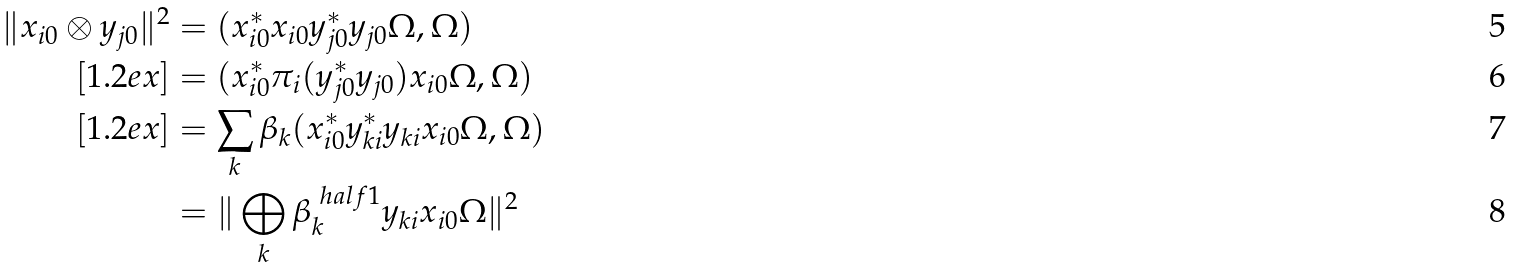<formula> <loc_0><loc_0><loc_500><loc_500>\| x _ { i 0 } \otimes y _ { j 0 } \| ^ { 2 } & = ( x _ { i 0 } ^ { * } x _ { i 0 } y _ { j 0 } ^ { * } y _ { j 0 } \Omega , \Omega ) \\ [ 1 . 2 e x ] & = ( x _ { i 0 } ^ { * } \pi _ { i } ( y _ { j 0 } ^ { * } y _ { j 0 } ) x _ { i 0 } \Omega , \Omega ) \\ [ 1 . 2 e x ] & = \sum _ { k } \beta _ { k } ( x _ { i 0 } ^ { * } y _ { k i } ^ { * } y _ { k i } x _ { i 0 } \Omega , \Omega ) \\ & = \| \bigoplus _ { k } \beta _ { k } ^ { \ h a l f { 1 } } y _ { k i } x _ { i 0 } \Omega \| ^ { 2 }</formula> 